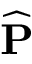<formula> <loc_0><loc_0><loc_500><loc_500>\widehat { P }</formula> 